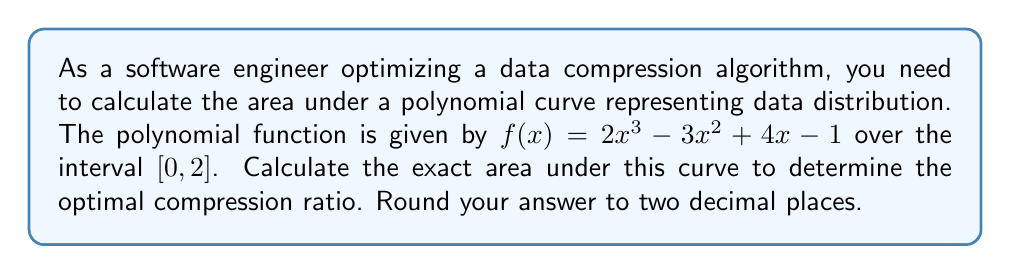Can you solve this math problem? To calculate the area under the polynomial curve, we need to use definite integration. The steps are as follows:

1) The area under the curve is given by the definite integral:

   $$A = \int_{0}^{2} (2x^3 - 3x^2 + 4x - 1) dx$$

2) Integrate the polynomial term by term:
   
   $$A = \left[\frac{1}{2}x^4 - x^3 + 2x^2 - x\right]_{0}^{2}$$

3) Evaluate the integral at the upper and lower bounds:
   
   $$A = \left(\frac{1}{2}(2^4) - (2^3) + 2(2^2) - 2\right) - \left(\frac{1}{2}(0^4) - (0^3) + 2(0^2) - 0\right)$$

4) Simplify:
   
   $$A = (8 - 8 + 8 - 2) - (0 - 0 + 0 - 0) = 6$$

5) The exact area is 6 square units.

6) Rounding to two decimal places: 6.00

This area represents the total amount of data distribution, which can be used to optimize the compression algorithm by allocating appropriate resources based on the data density in different regions.
Answer: 6.00 square units 